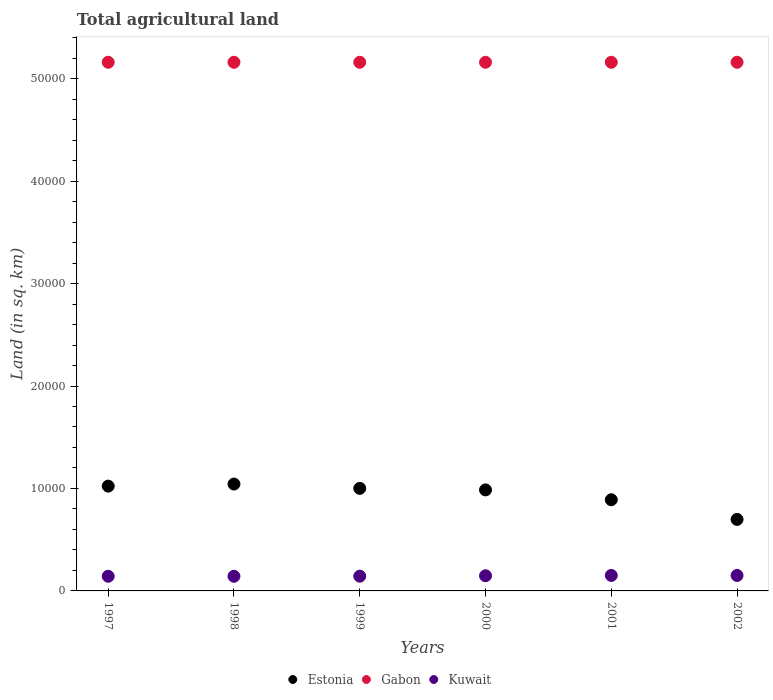Is the number of dotlines equal to the number of legend labels?
Your answer should be compact. Yes. What is the total agricultural land in Kuwait in 1999?
Offer a terse response. 1440. Across all years, what is the maximum total agricultural land in Gabon?
Ensure brevity in your answer.  5.16e+04. Across all years, what is the minimum total agricultural land in Gabon?
Ensure brevity in your answer.  5.16e+04. In which year was the total agricultural land in Kuwait maximum?
Make the answer very short. 2001. What is the total total agricultural land in Estonia in the graph?
Your answer should be compact. 5.64e+04. What is the difference between the total agricultural land in Kuwait in 1999 and that in 2000?
Your answer should be compact. -40. What is the difference between the total agricultural land in Gabon in 1998 and the total agricultural land in Estonia in 2000?
Give a very brief answer. 4.17e+04. What is the average total agricultural land in Kuwait per year?
Your answer should be very brief. 1466.67. In the year 2000, what is the difference between the total agricultural land in Gabon and total agricultural land in Kuwait?
Ensure brevity in your answer.  5.01e+04. In how many years, is the total agricultural land in Gabon greater than 34000 sq.km?
Give a very brief answer. 6. What is the ratio of the total agricultural land in Estonia in 1997 to that in 1999?
Give a very brief answer. 1.02. Is the total agricultural land in Gabon in 1998 less than that in 2002?
Keep it short and to the point. No. What is the difference between the highest and the lowest total agricultural land in Kuwait?
Offer a very short reply. 80. In how many years, is the total agricultural land in Gabon greater than the average total agricultural land in Gabon taken over all years?
Your response must be concise. 0. Is the sum of the total agricultural land in Gabon in 1999 and 2000 greater than the maximum total agricultural land in Kuwait across all years?
Your response must be concise. Yes. Is it the case that in every year, the sum of the total agricultural land in Kuwait and total agricultural land in Gabon  is greater than the total agricultural land in Estonia?
Offer a terse response. Yes. How many dotlines are there?
Your answer should be very brief. 3. Are the values on the major ticks of Y-axis written in scientific E-notation?
Offer a terse response. No. Does the graph contain any zero values?
Offer a very short reply. No. How many legend labels are there?
Offer a terse response. 3. How are the legend labels stacked?
Provide a succinct answer. Horizontal. What is the title of the graph?
Provide a short and direct response. Total agricultural land. Does "Bolivia" appear as one of the legend labels in the graph?
Provide a short and direct response. No. What is the label or title of the X-axis?
Your answer should be very brief. Years. What is the label or title of the Y-axis?
Ensure brevity in your answer.  Land (in sq. km). What is the Land (in sq. km) in Estonia in 1997?
Provide a succinct answer. 1.02e+04. What is the Land (in sq. km) in Gabon in 1997?
Your response must be concise. 5.16e+04. What is the Land (in sq. km) of Kuwait in 1997?
Make the answer very short. 1430. What is the Land (in sq. km) in Estonia in 1998?
Give a very brief answer. 1.04e+04. What is the Land (in sq. km) in Gabon in 1998?
Your response must be concise. 5.16e+04. What is the Land (in sq. km) of Kuwait in 1998?
Your answer should be very brief. 1430. What is the Land (in sq. km) of Estonia in 1999?
Provide a succinct answer. 1.00e+04. What is the Land (in sq. km) of Gabon in 1999?
Ensure brevity in your answer.  5.16e+04. What is the Land (in sq. km) in Kuwait in 1999?
Offer a very short reply. 1440. What is the Land (in sq. km) in Estonia in 2000?
Provide a short and direct response. 9860. What is the Land (in sq. km) of Gabon in 2000?
Give a very brief answer. 5.16e+04. What is the Land (in sq. km) of Kuwait in 2000?
Your answer should be compact. 1480. What is the Land (in sq. km) of Estonia in 2001?
Make the answer very short. 8900. What is the Land (in sq. km) in Gabon in 2001?
Offer a very short reply. 5.16e+04. What is the Land (in sq. km) in Kuwait in 2001?
Your response must be concise. 1510. What is the Land (in sq. km) in Estonia in 2002?
Keep it short and to the point. 6980. What is the Land (in sq. km) in Gabon in 2002?
Offer a very short reply. 5.16e+04. What is the Land (in sq. km) in Kuwait in 2002?
Offer a terse response. 1510. Across all years, what is the maximum Land (in sq. km) in Estonia?
Your response must be concise. 1.04e+04. Across all years, what is the maximum Land (in sq. km) in Gabon?
Provide a succinct answer. 5.16e+04. Across all years, what is the maximum Land (in sq. km) in Kuwait?
Your answer should be very brief. 1510. Across all years, what is the minimum Land (in sq. km) of Estonia?
Your response must be concise. 6980. Across all years, what is the minimum Land (in sq. km) in Gabon?
Provide a succinct answer. 5.16e+04. Across all years, what is the minimum Land (in sq. km) of Kuwait?
Provide a short and direct response. 1430. What is the total Land (in sq. km) in Estonia in the graph?
Keep it short and to the point. 5.64e+04. What is the total Land (in sq. km) in Gabon in the graph?
Provide a short and direct response. 3.10e+05. What is the total Land (in sq. km) in Kuwait in the graph?
Give a very brief answer. 8800. What is the difference between the Land (in sq. km) of Estonia in 1997 and that in 1998?
Your answer should be compact. -200. What is the difference between the Land (in sq. km) in Kuwait in 1997 and that in 1998?
Provide a short and direct response. 0. What is the difference between the Land (in sq. km) in Estonia in 1997 and that in 1999?
Your answer should be very brief. 220. What is the difference between the Land (in sq. km) in Estonia in 1997 and that in 2000?
Keep it short and to the point. 370. What is the difference between the Land (in sq. km) of Gabon in 1997 and that in 2000?
Keep it short and to the point. 0. What is the difference between the Land (in sq. km) in Estonia in 1997 and that in 2001?
Provide a succinct answer. 1330. What is the difference between the Land (in sq. km) in Kuwait in 1997 and that in 2001?
Offer a very short reply. -80. What is the difference between the Land (in sq. km) of Estonia in 1997 and that in 2002?
Provide a short and direct response. 3250. What is the difference between the Land (in sq. km) of Gabon in 1997 and that in 2002?
Ensure brevity in your answer.  0. What is the difference between the Land (in sq. km) of Kuwait in 1997 and that in 2002?
Give a very brief answer. -80. What is the difference between the Land (in sq. km) in Estonia in 1998 and that in 1999?
Keep it short and to the point. 420. What is the difference between the Land (in sq. km) of Kuwait in 1998 and that in 1999?
Keep it short and to the point. -10. What is the difference between the Land (in sq. km) of Estonia in 1998 and that in 2000?
Offer a very short reply. 570. What is the difference between the Land (in sq. km) of Gabon in 1998 and that in 2000?
Your answer should be very brief. 0. What is the difference between the Land (in sq. km) in Kuwait in 1998 and that in 2000?
Offer a terse response. -50. What is the difference between the Land (in sq. km) of Estonia in 1998 and that in 2001?
Make the answer very short. 1530. What is the difference between the Land (in sq. km) in Gabon in 1998 and that in 2001?
Provide a short and direct response. 0. What is the difference between the Land (in sq. km) in Kuwait in 1998 and that in 2001?
Your response must be concise. -80. What is the difference between the Land (in sq. km) in Estonia in 1998 and that in 2002?
Provide a succinct answer. 3450. What is the difference between the Land (in sq. km) of Kuwait in 1998 and that in 2002?
Your answer should be compact. -80. What is the difference between the Land (in sq. km) of Estonia in 1999 and that in 2000?
Ensure brevity in your answer.  150. What is the difference between the Land (in sq. km) in Gabon in 1999 and that in 2000?
Your response must be concise. 0. What is the difference between the Land (in sq. km) in Estonia in 1999 and that in 2001?
Provide a short and direct response. 1110. What is the difference between the Land (in sq. km) in Gabon in 1999 and that in 2001?
Your answer should be compact. 0. What is the difference between the Land (in sq. km) of Kuwait in 1999 and that in 2001?
Ensure brevity in your answer.  -70. What is the difference between the Land (in sq. km) of Estonia in 1999 and that in 2002?
Ensure brevity in your answer.  3030. What is the difference between the Land (in sq. km) of Kuwait in 1999 and that in 2002?
Offer a terse response. -70. What is the difference between the Land (in sq. km) of Estonia in 2000 and that in 2001?
Offer a terse response. 960. What is the difference between the Land (in sq. km) in Gabon in 2000 and that in 2001?
Keep it short and to the point. 0. What is the difference between the Land (in sq. km) of Kuwait in 2000 and that in 2001?
Your response must be concise. -30. What is the difference between the Land (in sq. km) in Estonia in 2000 and that in 2002?
Make the answer very short. 2880. What is the difference between the Land (in sq. km) of Estonia in 2001 and that in 2002?
Provide a short and direct response. 1920. What is the difference between the Land (in sq. km) of Gabon in 2001 and that in 2002?
Give a very brief answer. 0. What is the difference between the Land (in sq. km) of Kuwait in 2001 and that in 2002?
Offer a terse response. 0. What is the difference between the Land (in sq. km) of Estonia in 1997 and the Land (in sq. km) of Gabon in 1998?
Provide a succinct answer. -4.14e+04. What is the difference between the Land (in sq. km) of Estonia in 1997 and the Land (in sq. km) of Kuwait in 1998?
Your answer should be very brief. 8800. What is the difference between the Land (in sq. km) of Gabon in 1997 and the Land (in sq. km) of Kuwait in 1998?
Your answer should be very brief. 5.02e+04. What is the difference between the Land (in sq. km) of Estonia in 1997 and the Land (in sq. km) of Gabon in 1999?
Your answer should be compact. -4.14e+04. What is the difference between the Land (in sq. km) in Estonia in 1997 and the Land (in sq. km) in Kuwait in 1999?
Give a very brief answer. 8790. What is the difference between the Land (in sq. km) of Gabon in 1997 and the Land (in sq. km) of Kuwait in 1999?
Give a very brief answer. 5.02e+04. What is the difference between the Land (in sq. km) of Estonia in 1997 and the Land (in sq. km) of Gabon in 2000?
Ensure brevity in your answer.  -4.14e+04. What is the difference between the Land (in sq. km) of Estonia in 1997 and the Land (in sq. km) of Kuwait in 2000?
Give a very brief answer. 8750. What is the difference between the Land (in sq. km) in Gabon in 1997 and the Land (in sq. km) in Kuwait in 2000?
Offer a terse response. 5.01e+04. What is the difference between the Land (in sq. km) of Estonia in 1997 and the Land (in sq. km) of Gabon in 2001?
Provide a succinct answer. -4.14e+04. What is the difference between the Land (in sq. km) in Estonia in 1997 and the Land (in sq. km) in Kuwait in 2001?
Your answer should be compact. 8720. What is the difference between the Land (in sq. km) in Gabon in 1997 and the Land (in sq. km) in Kuwait in 2001?
Your answer should be very brief. 5.01e+04. What is the difference between the Land (in sq. km) of Estonia in 1997 and the Land (in sq. km) of Gabon in 2002?
Keep it short and to the point. -4.14e+04. What is the difference between the Land (in sq. km) in Estonia in 1997 and the Land (in sq. km) in Kuwait in 2002?
Your answer should be compact. 8720. What is the difference between the Land (in sq. km) in Gabon in 1997 and the Land (in sq. km) in Kuwait in 2002?
Ensure brevity in your answer.  5.01e+04. What is the difference between the Land (in sq. km) in Estonia in 1998 and the Land (in sq. km) in Gabon in 1999?
Ensure brevity in your answer.  -4.12e+04. What is the difference between the Land (in sq. km) of Estonia in 1998 and the Land (in sq. km) of Kuwait in 1999?
Your answer should be very brief. 8990. What is the difference between the Land (in sq. km) in Gabon in 1998 and the Land (in sq. km) in Kuwait in 1999?
Your response must be concise. 5.02e+04. What is the difference between the Land (in sq. km) of Estonia in 1998 and the Land (in sq. km) of Gabon in 2000?
Keep it short and to the point. -4.12e+04. What is the difference between the Land (in sq. km) in Estonia in 1998 and the Land (in sq. km) in Kuwait in 2000?
Offer a terse response. 8950. What is the difference between the Land (in sq. km) of Gabon in 1998 and the Land (in sq. km) of Kuwait in 2000?
Your answer should be compact. 5.01e+04. What is the difference between the Land (in sq. km) of Estonia in 1998 and the Land (in sq. km) of Gabon in 2001?
Provide a short and direct response. -4.12e+04. What is the difference between the Land (in sq. km) in Estonia in 1998 and the Land (in sq. km) in Kuwait in 2001?
Provide a succinct answer. 8920. What is the difference between the Land (in sq. km) of Gabon in 1998 and the Land (in sq. km) of Kuwait in 2001?
Provide a succinct answer. 5.01e+04. What is the difference between the Land (in sq. km) in Estonia in 1998 and the Land (in sq. km) in Gabon in 2002?
Keep it short and to the point. -4.12e+04. What is the difference between the Land (in sq. km) in Estonia in 1998 and the Land (in sq. km) in Kuwait in 2002?
Provide a succinct answer. 8920. What is the difference between the Land (in sq. km) in Gabon in 1998 and the Land (in sq. km) in Kuwait in 2002?
Your answer should be compact. 5.01e+04. What is the difference between the Land (in sq. km) in Estonia in 1999 and the Land (in sq. km) in Gabon in 2000?
Provide a succinct answer. -4.16e+04. What is the difference between the Land (in sq. km) in Estonia in 1999 and the Land (in sq. km) in Kuwait in 2000?
Make the answer very short. 8530. What is the difference between the Land (in sq. km) in Gabon in 1999 and the Land (in sq. km) in Kuwait in 2000?
Your answer should be compact. 5.01e+04. What is the difference between the Land (in sq. km) of Estonia in 1999 and the Land (in sq. km) of Gabon in 2001?
Your response must be concise. -4.16e+04. What is the difference between the Land (in sq. km) in Estonia in 1999 and the Land (in sq. km) in Kuwait in 2001?
Offer a terse response. 8500. What is the difference between the Land (in sq. km) of Gabon in 1999 and the Land (in sq. km) of Kuwait in 2001?
Your answer should be very brief. 5.01e+04. What is the difference between the Land (in sq. km) in Estonia in 1999 and the Land (in sq. km) in Gabon in 2002?
Make the answer very short. -4.16e+04. What is the difference between the Land (in sq. km) in Estonia in 1999 and the Land (in sq. km) in Kuwait in 2002?
Ensure brevity in your answer.  8500. What is the difference between the Land (in sq. km) of Gabon in 1999 and the Land (in sq. km) of Kuwait in 2002?
Your answer should be compact. 5.01e+04. What is the difference between the Land (in sq. km) of Estonia in 2000 and the Land (in sq. km) of Gabon in 2001?
Your answer should be compact. -4.17e+04. What is the difference between the Land (in sq. km) of Estonia in 2000 and the Land (in sq. km) of Kuwait in 2001?
Ensure brevity in your answer.  8350. What is the difference between the Land (in sq. km) of Gabon in 2000 and the Land (in sq. km) of Kuwait in 2001?
Keep it short and to the point. 5.01e+04. What is the difference between the Land (in sq. km) of Estonia in 2000 and the Land (in sq. km) of Gabon in 2002?
Ensure brevity in your answer.  -4.17e+04. What is the difference between the Land (in sq. km) in Estonia in 2000 and the Land (in sq. km) in Kuwait in 2002?
Keep it short and to the point. 8350. What is the difference between the Land (in sq. km) of Gabon in 2000 and the Land (in sq. km) of Kuwait in 2002?
Offer a terse response. 5.01e+04. What is the difference between the Land (in sq. km) in Estonia in 2001 and the Land (in sq. km) in Gabon in 2002?
Offer a very short reply. -4.27e+04. What is the difference between the Land (in sq. km) of Estonia in 2001 and the Land (in sq. km) of Kuwait in 2002?
Your response must be concise. 7390. What is the difference between the Land (in sq. km) in Gabon in 2001 and the Land (in sq. km) in Kuwait in 2002?
Your answer should be very brief. 5.01e+04. What is the average Land (in sq. km) in Estonia per year?
Give a very brief answer. 9401.67. What is the average Land (in sq. km) in Gabon per year?
Your answer should be compact. 5.16e+04. What is the average Land (in sq. km) in Kuwait per year?
Provide a succinct answer. 1466.67. In the year 1997, what is the difference between the Land (in sq. km) in Estonia and Land (in sq. km) in Gabon?
Offer a very short reply. -4.14e+04. In the year 1997, what is the difference between the Land (in sq. km) in Estonia and Land (in sq. km) in Kuwait?
Your response must be concise. 8800. In the year 1997, what is the difference between the Land (in sq. km) of Gabon and Land (in sq. km) of Kuwait?
Offer a very short reply. 5.02e+04. In the year 1998, what is the difference between the Land (in sq. km) of Estonia and Land (in sq. km) of Gabon?
Provide a short and direct response. -4.12e+04. In the year 1998, what is the difference between the Land (in sq. km) in Estonia and Land (in sq. km) in Kuwait?
Offer a terse response. 9000. In the year 1998, what is the difference between the Land (in sq. km) of Gabon and Land (in sq. km) of Kuwait?
Your response must be concise. 5.02e+04. In the year 1999, what is the difference between the Land (in sq. km) in Estonia and Land (in sq. km) in Gabon?
Give a very brief answer. -4.16e+04. In the year 1999, what is the difference between the Land (in sq. km) in Estonia and Land (in sq. km) in Kuwait?
Your response must be concise. 8570. In the year 1999, what is the difference between the Land (in sq. km) of Gabon and Land (in sq. km) of Kuwait?
Keep it short and to the point. 5.02e+04. In the year 2000, what is the difference between the Land (in sq. km) in Estonia and Land (in sq. km) in Gabon?
Keep it short and to the point. -4.17e+04. In the year 2000, what is the difference between the Land (in sq. km) of Estonia and Land (in sq. km) of Kuwait?
Your answer should be very brief. 8380. In the year 2000, what is the difference between the Land (in sq. km) in Gabon and Land (in sq. km) in Kuwait?
Your answer should be very brief. 5.01e+04. In the year 2001, what is the difference between the Land (in sq. km) of Estonia and Land (in sq. km) of Gabon?
Ensure brevity in your answer.  -4.27e+04. In the year 2001, what is the difference between the Land (in sq. km) in Estonia and Land (in sq. km) in Kuwait?
Provide a short and direct response. 7390. In the year 2001, what is the difference between the Land (in sq. km) of Gabon and Land (in sq. km) of Kuwait?
Offer a very short reply. 5.01e+04. In the year 2002, what is the difference between the Land (in sq. km) of Estonia and Land (in sq. km) of Gabon?
Provide a short and direct response. -4.46e+04. In the year 2002, what is the difference between the Land (in sq. km) of Estonia and Land (in sq. km) of Kuwait?
Provide a short and direct response. 5470. In the year 2002, what is the difference between the Land (in sq. km) in Gabon and Land (in sq. km) in Kuwait?
Provide a succinct answer. 5.01e+04. What is the ratio of the Land (in sq. km) in Estonia in 1997 to that in 1998?
Keep it short and to the point. 0.98. What is the ratio of the Land (in sq. km) of Gabon in 1997 to that in 1998?
Your answer should be compact. 1. What is the ratio of the Land (in sq. km) of Kuwait in 1997 to that in 1998?
Give a very brief answer. 1. What is the ratio of the Land (in sq. km) of Kuwait in 1997 to that in 1999?
Offer a very short reply. 0.99. What is the ratio of the Land (in sq. km) of Estonia in 1997 to that in 2000?
Your response must be concise. 1.04. What is the ratio of the Land (in sq. km) of Gabon in 1997 to that in 2000?
Ensure brevity in your answer.  1. What is the ratio of the Land (in sq. km) of Kuwait in 1997 to that in 2000?
Give a very brief answer. 0.97. What is the ratio of the Land (in sq. km) in Estonia in 1997 to that in 2001?
Your response must be concise. 1.15. What is the ratio of the Land (in sq. km) in Kuwait in 1997 to that in 2001?
Your answer should be compact. 0.95. What is the ratio of the Land (in sq. km) in Estonia in 1997 to that in 2002?
Keep it short and to the point. 1.47. What is the ratio of the Land (in sq. km) in Gabon in 1997 to that in 2002?
Ensure brevity in your answer.  1. What is the ratio of the Land (in sq. km) of Kuwait in 1997 to that in 2002?
Your answer should be compact. 0.95. What is the ratio of the Land (in sq. km) of Estonia in 1998 to that in 1999?
Ensure brevity in your answer.  1.04. What is the ratio of the Land (in sq. km) in Kuwait in 1998 to that in 1999?
Ensure brevity in your answer.  0.99. What is the ratio of the Land (in sq. km) of Estonia in 1998 to that in 2000?
Keep it short and to the point. 1.06. What is the ratio of the Land (in sq. km) in Gabon in 1998 to that in 2000?
Make the answer very short. 1. What is the ratio of the Land (in sq. km) in Kuwait in 1998 to that in 2000?
Your answer should be very brief. 0.97. What is the ratio of the Land (in sq. km) in Estonia in 1998 to that in 2001?
Keep it short and to the point. 1.17. What is the ratio of the Land (in sq. km) of Gabon in 1998 to that in 2001?
Offer a terse response. 1. What is the ratio of the Land (in sq. km) of Kuwait in 1998 to that in 2001?
Your answer should be compact. 0.95. What is the ratio of the Land (in sq. km) in Estonia in 1998 to that in 2002?
Give a very brief answer. 1.49. What is the ratio of the Land (in sq. km) of Kuwait in 1998 to that in 2002?
Offer a terse response. 0.95. What is the ratio of the Land (in sq. km) of Estonia in 1999 to that in 2000?
Make the answer very short. 1.02. What is the ratio of the Land (in sq. km) in Estonia in 1999 to that in 2001?
Give a very brief answer. 1.12. What is the ratio of the Land (in sq. km) of Gabon in 1999 to that in 2001?
Ensure brevity in your answer.  1. What is the ratio of the Land (in sq. km) of Kuwait in 1999 to that in 2001?
Your response must be concise. 0.95. What is the ratio of the Land (in sq. km) of Estonia in 1999 to that in 2002?
Your answer should be compact. 1.43. What is the ratio of the Land (in sq. km) of Kuwait in 1999 to that in 2002?
Your answer should be compact. 0.95. What is the ratio of the Land (in sq. km) of Estonia in 2000 to that in 2001?
Provide a succinct answer. 1.11. What is the ratio of the Land (in sq. km) in Kuwait in 2000 to that in 2001?
Offer a very short reply. 0.98. What is the ratio of the Land (in sq. km) of Estonia in 2000 to that in 2002?
Give a very brief answer. 1.41. What is the ratio of the Land (in sq. km) in Kuwait in 2000 to that in 2002?
Make the answer very short. 0.98. What is the ratio of the Land (in sq. km) in Estonia in 2001 to that in 2002?
Your answer should be very brief. 1.28. What is the difference between the highest and the second highest Land (in sq. km) in Gabon?
Give a very brief answer. 0. What is the difference between the highest and the second highest Land (in sq. km) in Kuwait?
Your answer should be very brief. 0. What is the difference between the highest and the lowest Land (in sq. km) of Estonia?
Your response must be concise. 3450. What is the difference between the highest and the lowest Land (in sq. km) of Gabon?
Provide a succinct answer. 0. 